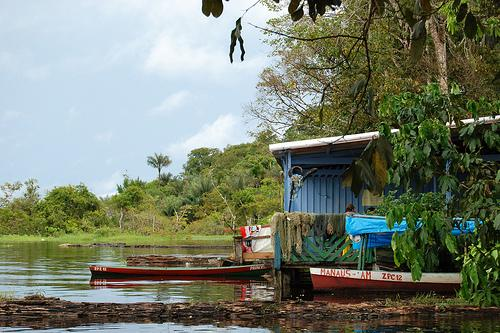Determine the emotion or atmosphere conveyed by the image based on the details in the image. The image conveys a peaceful and tranquil atmosphere with calm water, boats, trees, and a wooden river house. Analyze the interactions between objects in the image based on the details provided in the image. Dinghies are tied to the river house, while clothes are hanging on the porch, and boats are on the calm water nearby. Fishing nets hang on a fence, and trees surround the area, contributing to the serene atmosphere. Using the details provided in the image, create a brief description of the scene in the image. A blue river house on wooden stilts has a porch with clothes hanging to dry. Fishing nets are hanging on a fence, and several boats, including a red and white boat, are on the calm water nearby. Trees surround the body of water. What item is hanging on the porch of the river house? Clothes are hanging to dry on the porch. How many boats are mentioned in the image, and in which part of the image are they located? There are at least four boats mentioned, primarily located near the water or on the water in the image. What color is the house near the river in the image? The house near the river is painted blue. Based on the information provided in the image, count the total numbers of boats, trees, and clouds mentioned. At least four boats, two trees, and 11 clouds are mentioned. Suppose you are a tour guide narrating a photograph. Describe the primary objects in the image in a storytelling manner. As we gaze at this peaceful scene, a bright blue river house on wooden stilts captures our attention. Clothes sway gently in the breeze on the porch as fishing nets hang from a nearby fence. Calm waters surround the house, with the serene presence of a red and white boat anchored nearby, and magnificent trees offering a natural embrace to the scene. Interpret the nature of the event occurring in the scene. A calm and peaceful day by the river with boats and a house. Explain the purpose of the tarp on the boat. The tarp serves as a canopy for the boat. What is the emotion likely felt by the person sitting on the boat? The emotion cannot be determined without facial expression. Can you spot the playful dolphin emerging from the water near the boat? Describe its size, color, and movement as it leaps through the water in excitement. No, it's not mentioned in the image. Create a short poem inspired by the scene. By the calm river's side, a blue house stands, Identify the colors of the boat and whether it is moving or stationary. Red, white, and stationary What are the leaves of the tree near the water like? The leaves of the tall palm tree are slender and elongated. What type of building is next to the river? A blue wooden river house on stilts with a porch. What color is the house on the river? Blue Find a connection between the blue boat house and the river. The blue boat house is built near the river to provide easy access for boats. Infer the relationship between the trees around the water and boat. The trees provide a natural environment for the boat and the water. What does the number 12 on the boat signify? The letters and numbers on the boat. What letters can be spotted on the boat? M, S, and 12 Describe the boat in the water. A red and white boat with writing on the side, and a person sitting. How is the weather depicted in the image? Sunny with white clouds in a blue sky. List the objects found on the dock. Fishing nets, a tarp, and a boat in the water. Choose the correct type of tree near the water: oak, palm, or maple. Palm Describe the structure of the wooden dock on the lake. A wooden dock with fishing nets and a boat nearby. What are the clothes doing on the porch? The clothes are hanging to dry on the porch. 